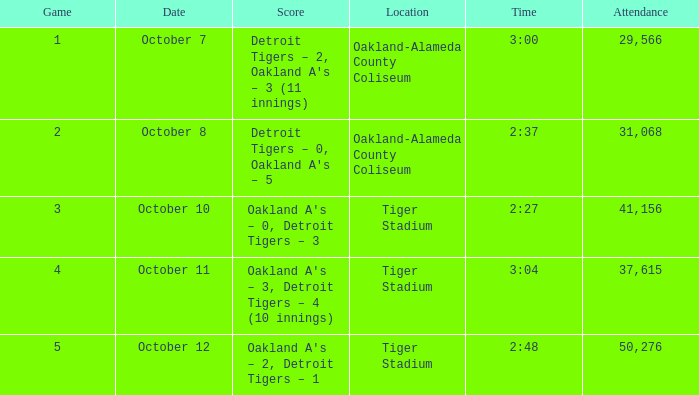What is the number of people in attendance at Oakland-Alameda County Coliseum, and game is 2? 31068.0. 